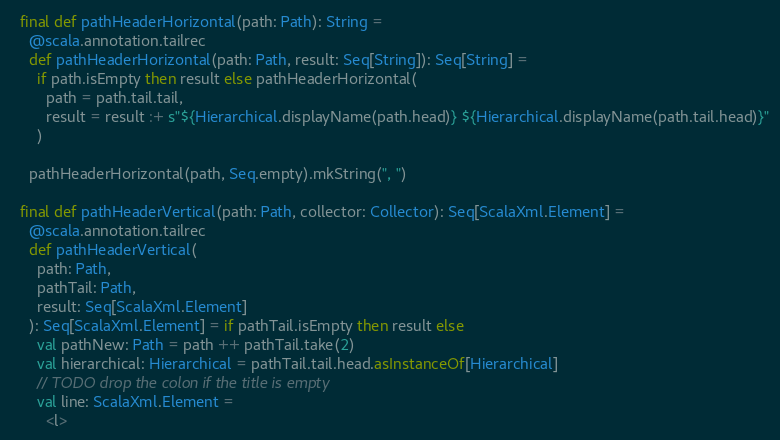<code> <loc_0><loc_0><loc_500><loc_500><_Scala_>
  final def pathHeaderHorizontal(path: Path): String =
    @scala.annotation.tailrec
    def pathHeaderHorizontal(path: Path, result: Seq[String]): Seq[String] =
      if path.isEmpty then result else pathHeaderHorizontal(
        path = path.tail.tail,
        result = result :+ s"${Hierarchical.displayName(path.head)} ${Hierarchical.displayName(path.tail.head)}"
      )

    pathHeaderHorizontal(path, Seq.empty).mkString(", ")

  final def pathHeaderVertical(path: Path, collector: Collector): Seq[ScalaXml.Element] =
    @scala.annotation.tailrec
    def pathHeaderVertical(
      path: Path,
      pathTail: Path,
      result: Seq[ScalaXml.Element]
    ): Seq[ScalaXml.Element] = if pathTail.isEmpty then result else
      val pathNew: Path = path ++ pathTail.take(2)
      val hierarchical: Hierarchical = pathTail.tail.head.asInstanceOf[Hierarchical]
      // TODO drop the colon if the title is empty
      val line: ScalaXml.Element =
        <l></code> 